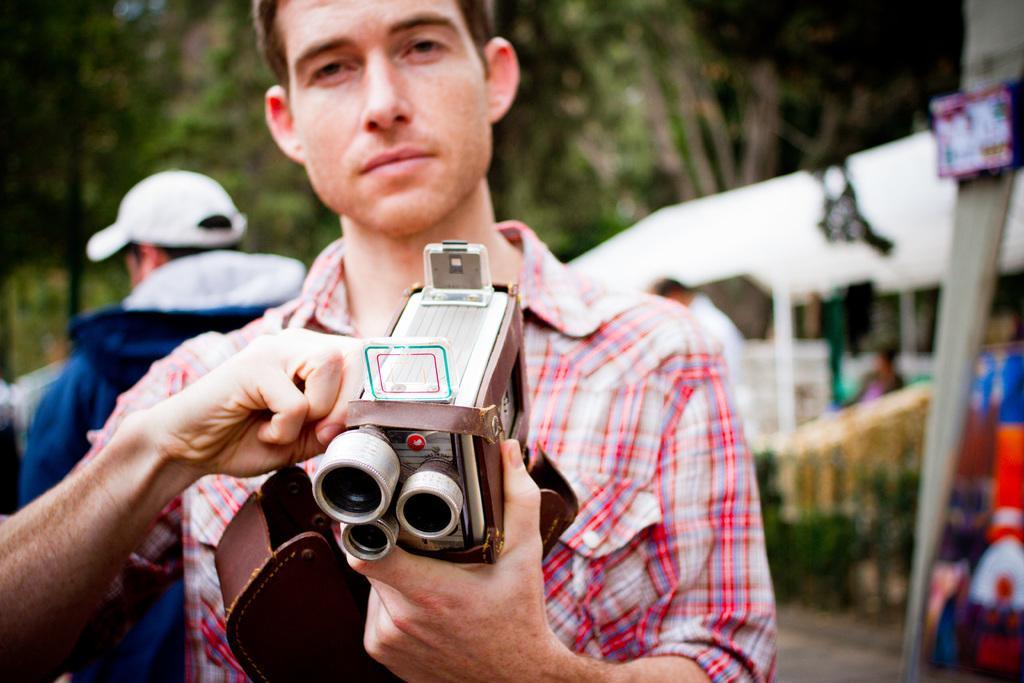Please provide a concise description of this image. a person is standing, holding a object in his hand. behind him at the left there is another person. at the back there are trees. 